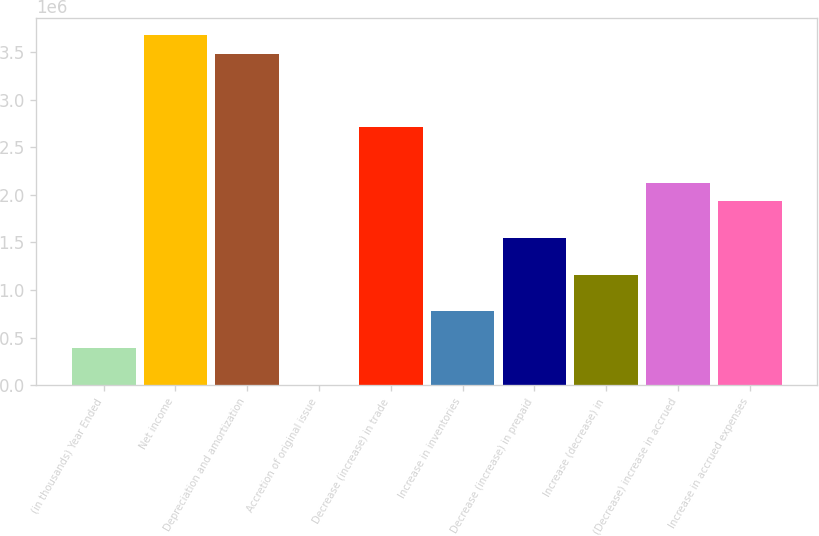<chart> <loc_0><loc_0><loc_500><loc_500><bar_chart><fcel>(in thousands) Year Ended<fcel>Net income<fcel>Depreciation and amortization<fcel>Accretion of original issue<fcel>Decrease (increase) in trade<fcel>Increase in inventories<fcel>Decrease (increase) in prepaid<fcel>Increase (decrease) in<fcel>(Decrease) increase in accrued<fcel>Increase in accrued expenses<nl><fcel>388444<fcel>3.67483e+06<fcel>3.48151e+06<fcel>1810<fcel>2.70825e+06<fcel>775078<fcel>1.54835e+06<fcel>1.16171e+06<fcel>2.1283e+06<fcel>1.93498e+06<nl></chart> 